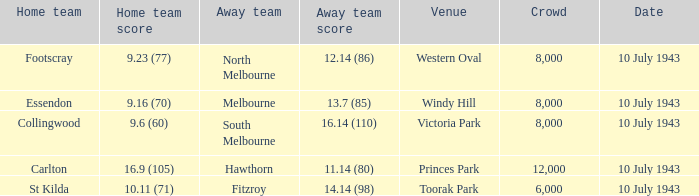When the Away team scored 14.14 (98), which Venue did the game take place? Toorak Park. 